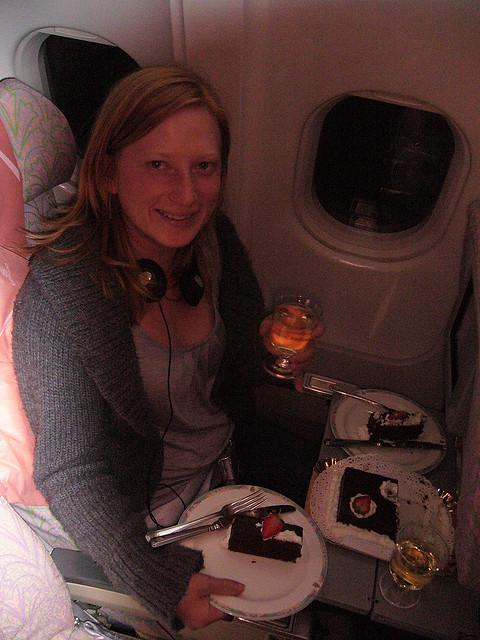Where is this woman feasting?

Choices:
A) airplane
B) train
C) subway
D) bus airplane 